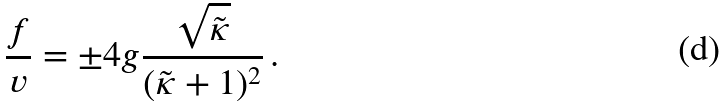Convert formula to latex. <formula><loc_0><loc_0><loc_500><loc_500>\frac { f } { v } = \pm 4 g \frac { \sqrt { \tilde { \kappa } } } { ( \tilde { \kappa } + 1 ) ^ { 2 } } \, .</formula> 